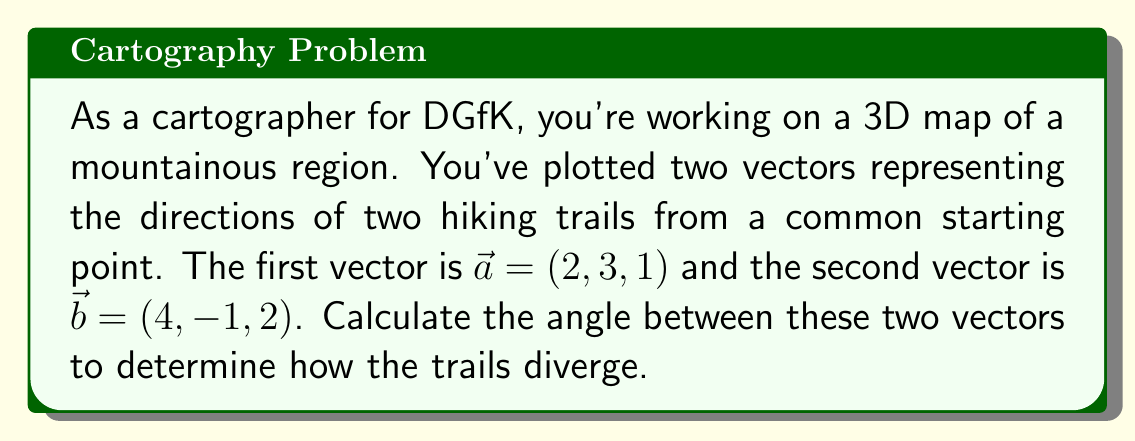Solve this math problem. To find the angle between two vectors in 3D space, we can use the dot product formula:

$$\cos \theta = \frac{\vec{a} \cdot \vec{b}}{|\vec{a}| |\vec{b}|}$$

Where $\theta$ is the angle between the vectors, $\vec{a} \cdot \vec{b}$ is the dot product, and $|\vec{a}|$ and $|\vec{b}|$ are the magnitudes of the vectors.

Step 1: Calculate the dot product $\vec{a} \cdot \vec{b}$
$$\vec{a} \cdot \vec{b} = (2)(4) + (3)(-1) + (1)(2) = 8 - 3 + 2 = 7$$

Step 2: Calculate the magnitudes of the vectors
$$|\vec{a}| = \sqrt{2^2 + 3^2 + 1^2} = \sqrt{4 + 9 + 1} = \sqrt{14}$$
$$|\vec{b}| = \sqrt{4^2 + (-1)^2 + 2^2} = \sqrt{16 + 1 + 4} = \sqrt{21}$$

Step 3: Substitute into the formula
$$\cos \theta = \frac{7}{\sqrt{14} \sqrt{21}}$$

Step 4: Simplify
$$\cos \theta = \frac{7}{\sqrt{294}}$$

Step 5: Take the inverse cosine (arccos) of both sides
$$\theta = \arccos\left(\frac{7}{\sqrt{294}}\right)$$

Step 6: Calculate the result (approximately)
$$\theta \approx 1.1071 \text{ radians}$$

Convert to degrees:
$$\theta \approx 1.1071 \times \frac{180}{\pi} \approx 63.43°$$
Answer: The angle between the two vectors is approximately 63.43°. 